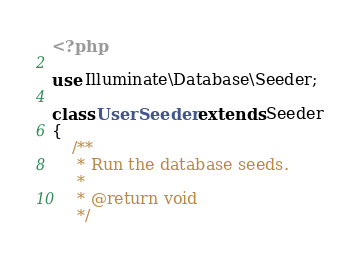Convert code to text. <code><loc_0><loc_0><loc_500><loc_500><_PHP_><?php

use Illuminate\Database\Seeder;

class UserSeeder extends Seeder
{
    /**
     * Run the database seeds.
     *
     * @return void
     */</code> 